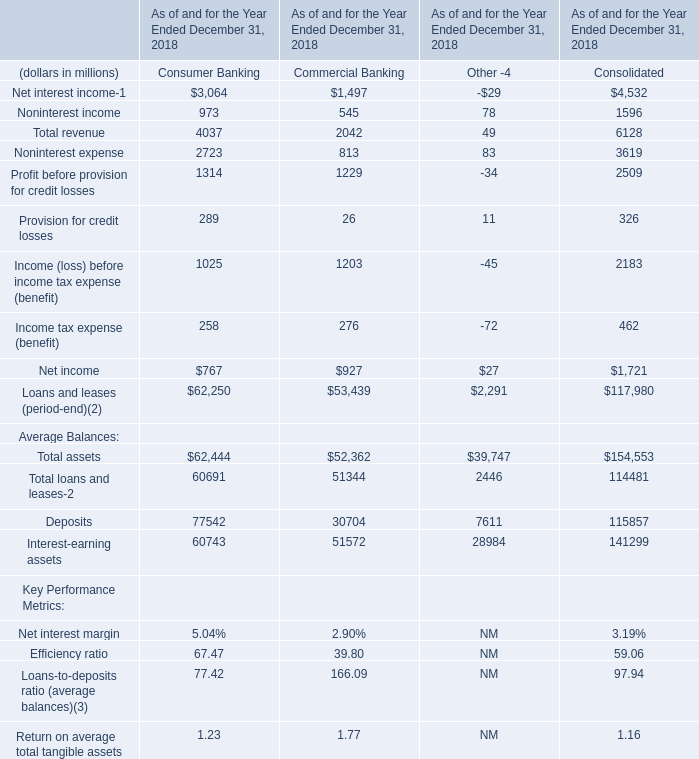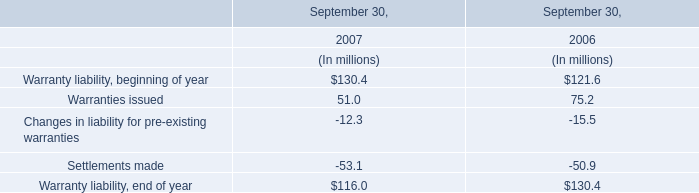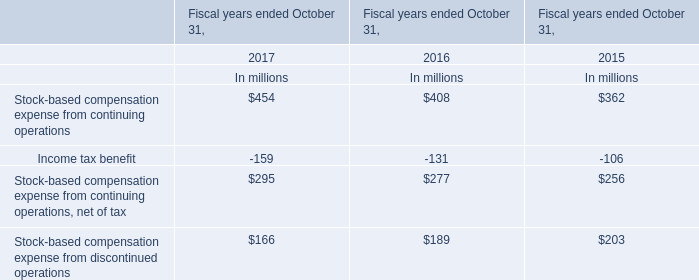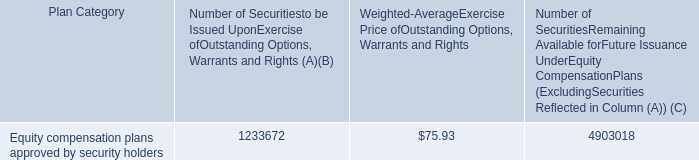What is the sum of the net income in the section where revenue is greater than 3000? (in million) 
Computations: (((4037 - 2723) - 289) - 258)
Answer: 767.0. what is the ratio of issued units to outstanding units? 
Computations: (1233672 / 4903018)
Answer: 0.25161. 